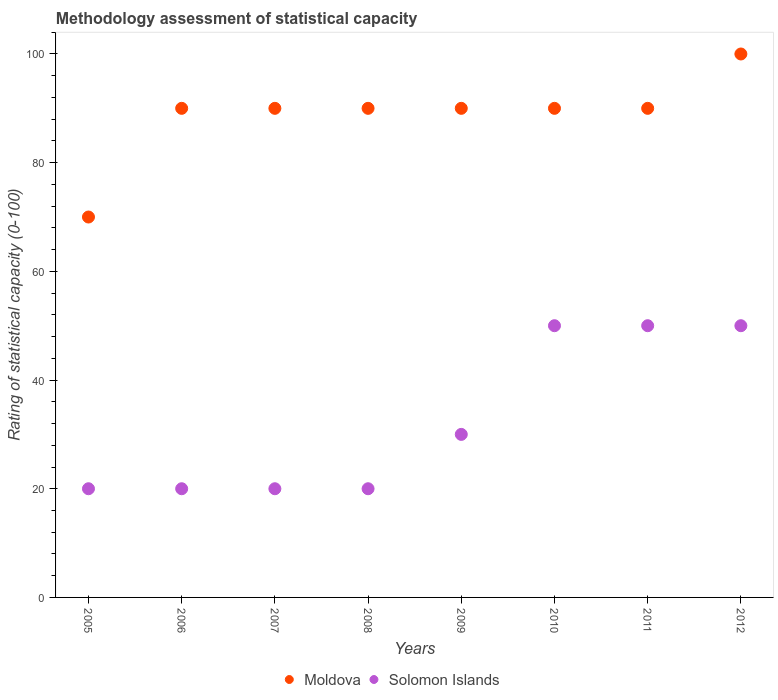Is the number of dotlines equal to the number of legend labels?
Your response must be concise. Yes. Across all years, what is the maximum rating of statistical capacity in Moldova?
Your answer should be compact. 100. Across all years, what is the minimum rating of statistical capacity in Solomon Islands?
Provide a short and direct response. 20. What is the total rating of statistical capacity in Solomon Islands in the graph?
Make the answer very short. 260. What is the difference between the rating of statistical capacity in Moldova in 2005 and the rating of statistical capacity in Solomon Islands in 2012?
Your answer should be compact. 20. What is the average rating of statistical capacity in Moldova per year?
Offer a terse response. 88.75. In the year 2011, what is the difference between the rating of statistical capacity in Moldova and rating of statistical capacity in Solomon Islands?
Your answer should be compact. 40. In how many years, is the rating of statistical capacity in Solomon Islands greater than 76?
Provide a short and direct response. 0. What is the ratio of the rating of statistical capacity in Solomon Islands in 2007 to that in 2009?
Your answer should be very brief. 0.67. Is the difference between the rating of statistical capacity in Moldova in 2007 and 2011 greater than the difference between the rating of statistical capacity in Solomon Islands in 2007 and 2011?
Provide a succinct answer. Yes. What is the difference between the highest and the second highest rating of statistical capacity in Solomon Islands?
Keep it short and to the point. 0. What is the difference between the highest and the lowest rating of statistical capacity in Moldova?
Offer a very short reply. 30. In how many years, is the rating of statistical capacity in Moldova greater than the average rating of statistical capacity in Moldova taken over all years?
Provide a succinct answer. 7. Is the sum of the rating of statistical capacity in Solomon Islands in 2008 and 2009 greater than the maximum rating of statistical capacity in Moldova across all years?
Offer a very short reply. No. Is the rating of statistical capacity in Solomon Islands strictly greater than the rating of statistical capacity in Moldova over the years?
Your response must be concise. No. Is the rating of statistical capacity in Moldova strictly less than the rating of statistical capacity in Solomon Islands over the years?
Your response must be concise. No. How many dotlines are there?
Your answer should be compact. 2. Does the graph contain any zero values?
Your answer should be very brief. No. Does the graph contain grids?
Your answer should be compact. No. Where does the legend appear in the graph?
Ensure brevity in your answer.  Bottom center. How many legend labels are there?
Provide a short and direct response. 2. How are the legend labels stacked?
Provide a succinct answer. Horizontal. What is the title of the graph?
Your answer should be compact. Methodology assessment of statistical capacity. Does "Estonia" appear as one of the legend labels in the graph?
Ensure brevity in your answer.  No. What is the label or title of the Y-axis?
Your response must be concise. Rating of statistical capacity (0-100). What is the Rating of statistical capacity (0-100) in Moldova in 2006?
Provide a succinct answer. 90. What is the Rating of statistical capacity (0-100) in Solomon Islands in 2006?
Provide a short and direct response. 20. What is the Rating of statistical capacity (0-100) in Moldova in 2009?
Provide a short and direct response. 90. Across all years, what is the maximum Rating of statistical capacity (0-100) in Moldova?
Keep it short and to the point. 100. Across all years, what is the maximum Rating of statistical capacity (0-100) of Solomon Islands?
Keep it short and to the point. 50. Across all years, what is the minimum Rating of statistical capacity (0-100) in Solomon Islands?
Make the answer very short. 20. What is the total Rating of statistical capacity (0-100) in Moldova in the graph?
Keep it short and to the point. 710. What is the total Rating of statistical capacity (0-100) in Solomon Islands in the graph?
Ensure brevity in your answer.  260. What is the difference between the Rating of statistical capacity (0-100) in Moldova in 2005 and that in 2006?
Offer a very short reply. -20. What is the difference between the Rating of statistical capacity (0-100) of Moldova in 2005 and that in 2007?
Offer a very short reply. -20. What is the difference between the Rating of statistical capacity (0-100) in Solomon Islands in 2005 and that in 2007?
Provide a succinct answer. 0. What is the difference between the Rating of statistical capacity (0-100) in Moldova in 2005 and that in 2008?
Your answer should be compact. -20. What is the difference between the Rating of statistical capacity (0-100) of Solomon Islands in 2005 and that in 2009?
Your answer should be very brief. -10. What is the difference between the Rating of statistical capacity (0-100) in Solomon Islands in 2005 and that in 2010?
Keep it short and to the point. -30. What is the difference between the Rating of statistical capacity (0-100) in Solomon Islands in 2005 and that in 2011?
Your answer should be very brief. -30. What is the difference between the Rating of statistical capacity (0-100) of Moldova in 2006 and that in 2007?
Your response must be concise. 0. What is the difference between the Rating of statistical capacity (0-100) of Solomon Islands in 2006 and that in 2007?
Keep it short and to the point. 0. What is the difference between the Rating of statistical capacity (0-100) of Solomon Islands in 2006 and that in 2008?
Your answer should be very brief. 0. What is the difference between the Rating of statistical capacity (0-100) in Moldova in 2006 and that in 2009?
Your response must be concise. 0. What is the difference between the Rating of statistical capacity (0-100) of Solomon Islands in 2006 and that in 2010?
Offer a terse response. -30. What is the difference between the Rating of statistical capacity (0-100) in Moldova in 2006 and that in 2011?
Ensure brevity in your answer.  0. What is the difference between the Rating of statistical capacity (0-100) of Solomon Islands in 2006 and that in 2012?
Your answer should be very brief. -30. What is the difference between the Rating of statistical capacity (0-100) of Solomon Islands in 2007 and that in 2008?
Your answer should be very brief. 0. What is the difference between the Rating of statistical capacity (0-100) in Moldova in 2007 and that in 2009?
Ensure brevity in your answer.  0. What is the difference between the Rating of statistical capacity (0-100) of Solomon Islands in 2007 and that in 2009?
Offer a very short reply. -10. What is the difference between the Rating of statistical capacity (0-100) in Solomon Islands in 2007 and that in 2010?
Your answer should be very brief. -30. What is the difference between the Rating of statistical capacity (0-100) in Moldova in 2007 and that in 2011?
Your answer should be very brief. 0. What is the difference between the Rating of statistical capacity (0-100) in Solomon Islands in 2007 and that in 2011?
Offer a terse response. -30. What is the difference between the Rating of statistical capacity (0-100) of Moldova in 2007 and that in 2012?
Ensure brevity in your answer.  -10. What is the difference between the Rating of statistical capacity (0-100) in Solomon Islands in 2007 and that in 2012?
Ensure brevity in your answer.  -30. What is the difference between the Rating of statistical capacity (0-100) in Moldova in 2008 and that in 2010?
Offer a terse response. 0. What is the difference between the Rating of statistical capacity (0-100) in Solomon Islands in 2008 and that in 2010?
Keep it short and to the point. -30. What is the difference between the Rating of statistical capacity (0-100) in Moldova in 2008 and that in 2011?
Make the answer very short. 0. What is the difference between the Rating of statistical capacity (0-100) in Solomon Islands in 2008 and that in 2012?
Your answer should be compact. -30. What is the difference between the Rating of statistical capacity (0-100) in Moldova in 2009 and that in 2010?
Provide a short and direct response. 0. What is the difference between the Rating of statistical capacity (0-100) of Solomon Islands in 2009 and that in 2011?
Offer a very short reply. -20. What is the difference between the Rating of statistical capacity (0-100) of Moldova in 2009 and that in 2012?
Your answer should be very brief. -10. What is the difference between the Rating of statistical capacity (0-100) of Solomon Islands in 2010 and that in 2012?
Your answer should be very brief. 0. What is the difference between the Rating of statistical capacity (0-100) of Solomon Islands in 2011 and that in 2012?
Offer a terse response. 0. What is the difference between the Rating of statistical capacity (0-100) of Moldova in 2005 and the Rating of statistical capacity (0-100) of Solomon Islands in 2007?
Your answer should be compact. 50. What is the difference between the Rating of statistical capacity (0-100) of Moldova in 2005 and the Rating of statistical capacity (0-100) of Solomon Islands in 2008?
Provide a short and direct response. 50. What is the difference between the Rating of statistical capacity (0-100) of Moldova in 2005 and the Rating of statistical capacity (0-100) of Solomon Islands in 2010?
Offer a terse response. 20. What is the difference between the Rating of statistical capacity (0-100) in Moldova in 2005 and the Rating of statistical capacity (0-100) in Solomon Islands in 2012?
Offer a terse response. 20. What is the difference between the Rating of statistical capacity (0-100) of Moldova in 2006 and the Rating of statistical capacity (0-100) of Solomon Islands in 2007?
Provide a short and direct response. 70. What is the difference between the Rating of statistical capacity (0-100) in Moldova in 2006 and the Rating of statistical capacity (0-100) in Solomon Islands in 2010?
Provide a short and direct response. 40. What is the difference between the Rating of statistical capacity (0-100) in Moldova in 2006 and the Rating of statistical capacity (0-100) in Solomon Islands in 2012?
Ensure brevity in your answer.  40. What is the difference between the Rating of statistical capacity (0-100) of Moldova in 2007 and the Rating of statistical capacity (0-100) of Solomon Islands in 2008?
Offer a terse response. 70. What is the difference between the Rating of statistical capacity (0-100) of Moldova in 2007 and the Rating of statistical capacity (0-100) of Solomon Islands in 2009?
Give a very brief answer. 60. What is the difference between the Rating of statistical capacity (0-100) in Moldova in 2007 and the Rating of statistical capacity (0-100) in Solomon Islands in 2012?
Offer a terse response. 40. What is the difference between the Rating of statistical capacity (0-100) in Moldova in 2008 and the Rating of statistical capacity (0-100) in Solomon Islands in 2009?
Provide a succinct answer. 60. What is the difference between the Rating of statistical capacity (0-100) in Moldova in 2008 and the Rating of statistical capacity (0-100) in Solomon Islands in 2010?
Keep it short and to the point. 40. What is the difference between the Rating of statistical capacity (0-100) in Moldova in 2009 and the Rating of statistical capacity (0-100) in Solomon Islands in 2010?
Keep it short and to the point. 40. What is the difference between the Rating of statistical capacity (0-100) in Moldova in 2009 and the Rating of statistical capacity (0-100) in Solomon Islands in 2012?
Your response must be concise. 40. What is the difference between the Rating of statistical capacity (0-100) in Moldova in 2010 and the Rating of statistical capacity (0-100) in Solomon Islands in 2011?
Offer a very short reply. 40. What is the difference between the Rating of statistical capacity (0-100) in Moldova in 2010 and the Rating of statistical capacity (0-100) in Solomon Islands in 2012?
Offer a very short reply. 40. What is the average Rating of statistical capacity (0-100) in Moldova per year?
Provide a short and direct response. 88.75. What is the average Rating of statistical capacity (0-100) in Solomon Islands per year?
Your response must be concise. 32.5. In the year 2007, what is the difference between the Rating of statistical capacity (0-100) of Moldova and Rating of statistical capacity (0-100) of Solomon Islands?
Your answer should be compact. 70. In the year 2008, what is the difference between the Rating of statistical capacity (0-100) of Moldova and Rating of statistical capacity (0-100) of Solomon Islands?
Ensure brevity in your answer.  70. In the year 2010, what is the difference between the Rating of statistical capacity (0-100) in Moldova and Rating of statistical capacity (0-100) in Solomon Islands?
Your answer should be compact. 40. In the year 2011, what is the difference between the Rating of statistical capacity (0-100) in Moldova and Rating of statistical capacity (0-100) in Solomon Islands?
Ensure brevity in your answer.  40. In the year 2012, what is the difference between the Rating of statistical capacity (0-100) of Moldova and Rating of statistical capacity (0-100) of Solomon Islands?
Your response must be concise. 50. What is the ratio of the Rating of statistical capacity (0-100) in Moldova in 2005 to that in 2006?
Make the answer very short. 0.78. What is the ratio of the Rating of statistical capacity (0-100) of Solomon Islands in 2005 to that in 2007?
Give a very brief answer. 1. What is the ratio of the Rating of statistical capacity (0-100) in Moldova in 2005 to that in 2008?
Your answer should be very brief. 0.78. What is the ratio of the Rating of statistical capacity (0-100) of Solomon Islands in 2005 to that in 2009?
Make the answer very short. 0.67. What is the ratio of the Rating of statistical capacity (0-100) in Moldova in 2005 to that in 2012?
Your answer should be compact. 0.7. What is the ratio of the Rating of statistical capacity (0-100) of Solomon Islands in 2005 to that in 2012?
Give a very brief answer. 0.4. What is the ratio of the Rating of statistical capacity (0-100) in Solomon Islands in 2006 to that in 2009?
Your answer should be compact. 0.67. What is the ratio of the Rating of statistical capacity (0-100) in Moldova in 2006 to that in 2010?
Your response must be concise. 1. What is the ratio of the Rating of statistical capacity (0-100) in Solomon Islands in 2006 to that in 2010?
Provide a short and direct response. 0.4. What is the ratio of the Rating of statistical capacity (0-100) of Moldova in 2006 to that in 2011?
Give a very brief answer. 1. What is the ratio of the Rating of statistical capacity (0-100) in Solomon Islands in 2006 to that in 2011?
Give a very brief answer. 0.4. What is the ratio of the Rating of statistical capacity (0-100) of Moldova in 2006 to that in 2012?
Give a very brief answer. 0.9. What is the ratio of the Rating of statistical capacity (0-100) of Moldova in 2007 to that in 2008?
Your answer should be compact. 1. What is the ratio of the Rating of statistical capacity (0-100) of Moldova in 2007 to that in 2009?
Your answer should be very brief. 1. What is the ratio of the Rating of statistical capacity (0-100) of Solomon Islands in 2007 to that in 2009?
Your answer should be compact. 0.67. What is the ratio of the Rating of statistical capacity (0-100) of Moldova in 2007 to that in 2010?
Make the answer very short. 1. What is the ratio of the Rating of statistical capacity (0-100) of Solomon Islands in 2007 to that in 2010?
Make the answer very short. 0.4. What is the ratio of the Rating of statistical capacity (0-100) of Moldova in 2007 to that in 2011?
Give a very brief answer. 1. What is the ratio of the Rating of statistical capacity (0-100) in Solomon Islands in 2007 to that in 2011?
Offer a very short reply. 0.4. What is the ratio of the Rating of statistical capacity (0-100) of Moldova in 2007 to that in 2012?
Offer a very short reply. 0.9. What is the ratio of the Rating of statistical capacity (0-100) in Solomon Islands in 2007 to that in 2012?
Offer a very short reply. 0.4. What is the ratio of the Rating of statistical capacity (0-100) in Moldova in 2008 to that in 2009?
Keep it short and to the point. 1. What is the ratio of the Rating of statistical capacity (0-100) in Moldova in 2008 to that in 2010?
Offer a terse response. 1. What is the ratio of the Rating of statistical capacity (0-100) in Moldova in 2008 to that in 2012?
Make the answer very short. 0.9. What is the ratio of the Rating of statistical capacity (0-100) of Solomon Islands in 2009 to that in 2011?
Offer a very short reply. 0.6. What is the ratio of the Rating of statistical capacity (0-100) in Moldova in 2009 to that in 2012?
Provide a short and direct response. 0.9. What is the ratio of the Rating of statistical capacity (0-100) in Moldova in 2010 to that in 2011?
Your response must be concise. 1. What is the ratio of the Rating of statistical capacity (0-100) of Solomon Islands in 2010 to that in 2011?
Make the answer very short. 1. What is the ratio of the Rating of statistical capacity (0-100) of Solomon Islands in 2010 to that in 2012?
Ensure brevity in your answer.  1. What is the ratio of the Rating of statistical capacity (0-100) of Solomon Islands in 2011 to that in 2012?
Give a very brief answer. 1. What is the difference between the highest and the second highest Rating of statistical capacity (0-100) of Solomon Islands?
Provide a short and direct response. 0. What is the difference between the highest and the lowest Rating of statistical capacity (0-100) in Solomon Islands?
Make the answer very short. 30. 